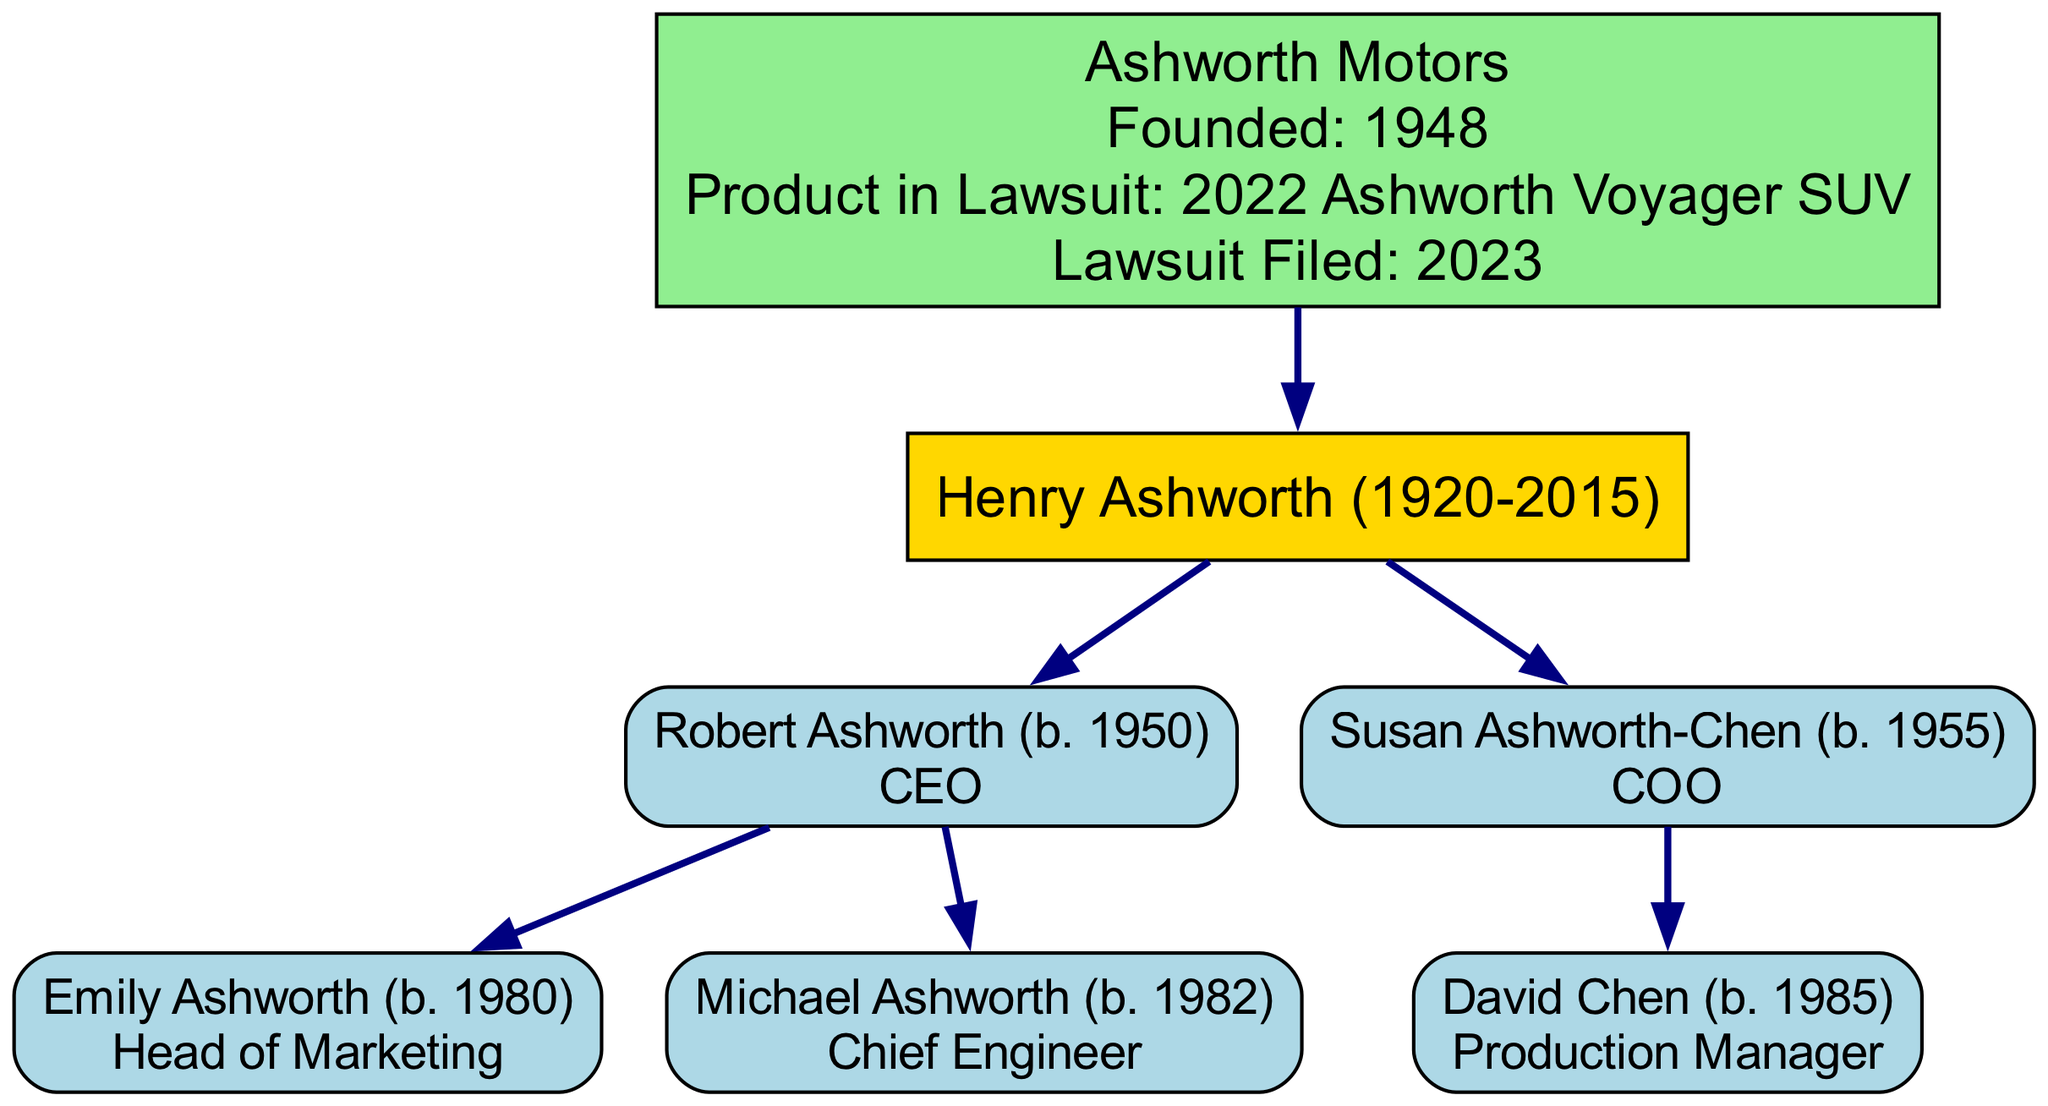What is the name of the founder? The diagram presents the founder as "Henry Ashworth (1920-2015)", who is clearly labeled as the founder of Ashworth Motors.
Answer: Henry Ashworth (1920-2015) Who is the CEO of Ashworth Motors? The diagram shows "Robert Ashworth (b. 1950)" as the child of the founder and identifies him with the role of CEO.
Answer: Robert Ashworth (b. 1950) How many children does the founder have? By analyzing the branches that stem from "Henry Ashworth" in the diagram, we find two direct children: "Robert Ashworth" and "Susan Ashworth-Chen".
Answer: 2 What role does Emily Ashworth have in the company? The diagram provides a label for "Emily Ashworth (b. 1980)", indicating her role as "Head of Marketing".
Answer: Head of Marketing Which family member is responsible for production management? The diagram identifies "David Chen (b. 1985)" as a child of "Susan Ashworth-Chen" and shows his role as "Production Manager".
Answer: David Chen (b. 1985) What year was Ashworth Motors founded? The information enclosed in the company node specifies that Ashworth Motors was founded in "1948".
Answer: 1948 How is Susan Ashworth-Chen related to the founder? The diagram shows a direct line from "Susan Ashworth-Chen" to "Henry Ashworth", indicating that she is his daughter.
Answer: Daughter In which year was the product liability lawsuit filed? The company node directly indicates that the lawsuit was filed in "2023".
Answer: 2023 Who are the grandchildren of Henry Ashworth? By tracing the branches under "Robert Ashworth" and "Susan Ashworth-Chen", we see that the grandchildren listed are "Emily Ashworth" and "Michael Ashworth" plus "David Chen".
Answer: Emily Ashworth, Michael Ashworth, David Chen 